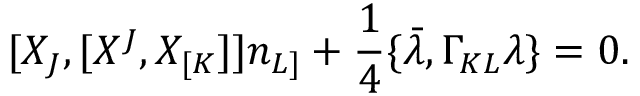<formula> <loc_0><loc_0><loc_500><loc_500>[ X _ { J } , [ X ^ { J } , X _ { [ K } ] ] n _ { L ] } + { \frac { 1 } { 4 } } \{ \bar { \lambda } , \Gamma _ { K L } \lambda \} = 0 .</formula> 